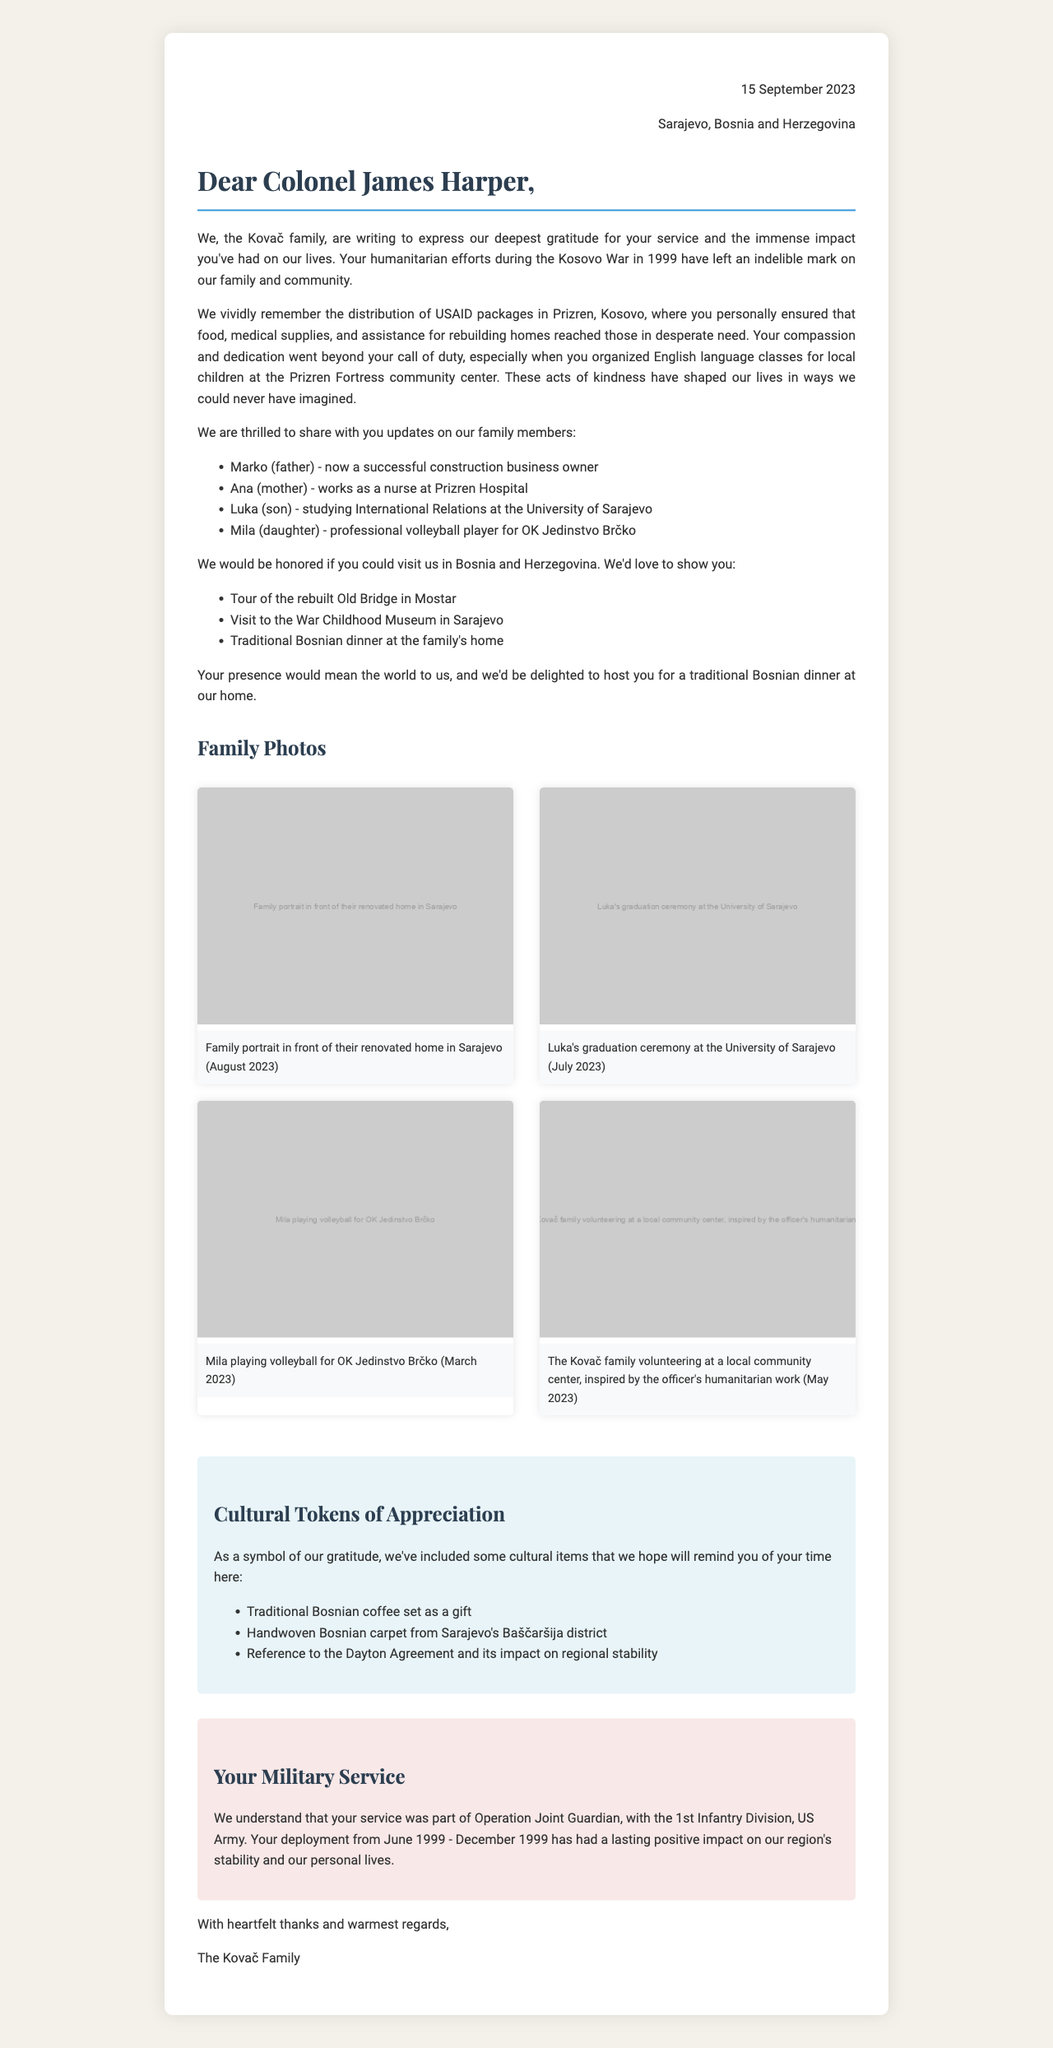what date was the letter written? The date of the letter is explicitly mentioned in the document.
Answer: 15 September 2023 who is the recipient of the letter? The letter specifies that it is addressed to Colonel James Harper.
Answer: Colonel James Harper which family is sending the letter? The sender's family name is provided in the letter.
Answer: Kovač what military operation is referenced in the document? The operation name is explicitly mentioned under the military context section.
Answer: Operation Joint Guardian how many family members are mentioned in the updates? The letter lists four family members in the updates section.
Answer: four which language classes were organized by the officer? The letter specifies the type of classes organized by Colonel Harper for local children.
Answer: English language classes what was Marko's occupation? The letter update mentions Marko's current professional status.
Answer: construction business owner when was the family portrait taken? The date of the family portrait is included in the accompanying photos section.
Answer: August 2023 what invitation is extended to Colonel Harper? The document includes a specific invitation mentioned towards the end.
Answer: visit to Bosnia and Herzegovina 